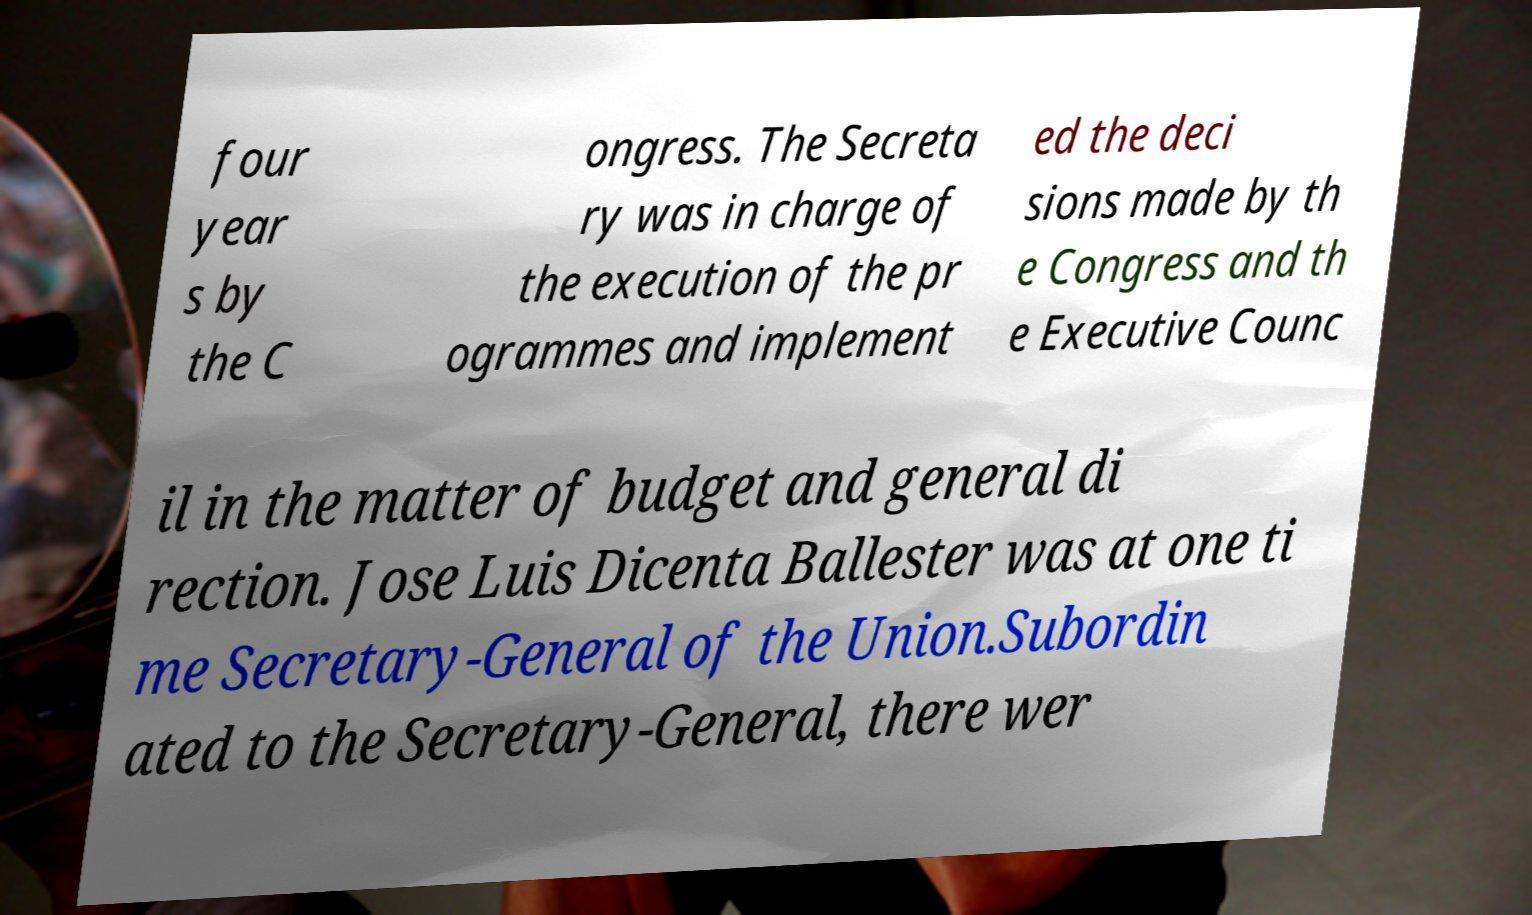Please identify and transcribe the text found in this image. four year s by the C ongress. The Secreta ry was in charge of the execution of the pr ogrammes and implement ed the deci sions made by th e Congress and th e Executive Counc il in the matter of budget and general di rection. Jose Luis Dicenta Ballester was at one ti me Secretary-General of the Union.Subordin ated to the Secretary-General, there wer 